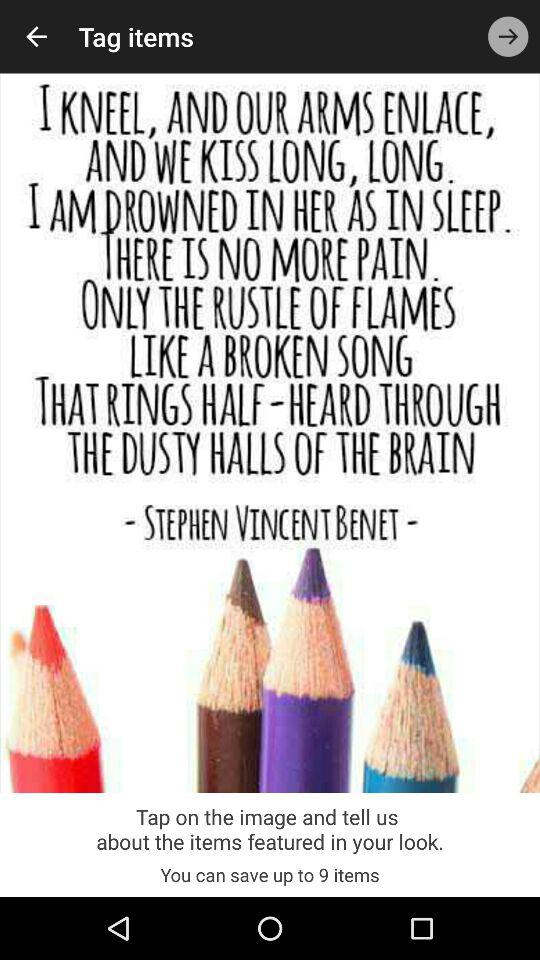What is the name of the poet? The name of the poet is Stephen Vincent Benet. 